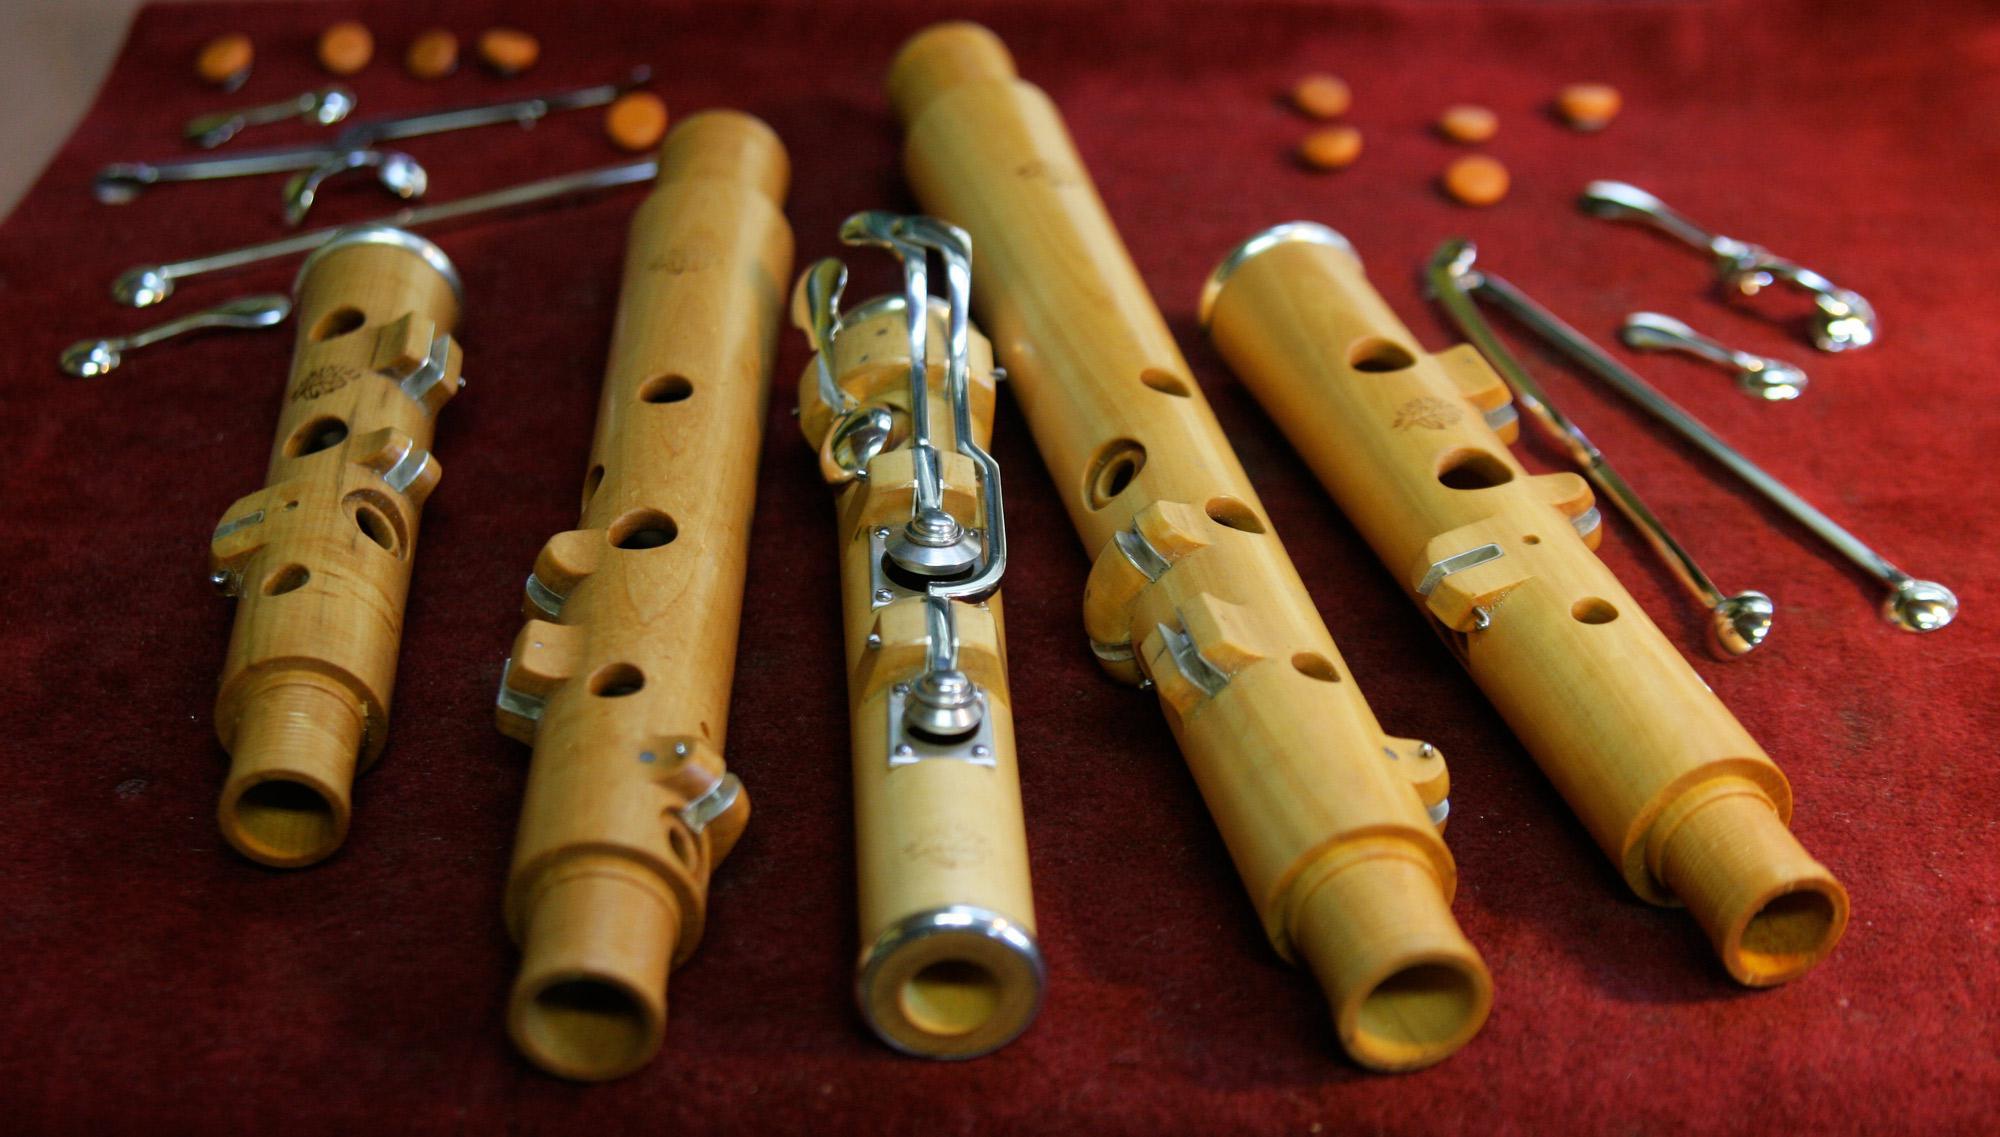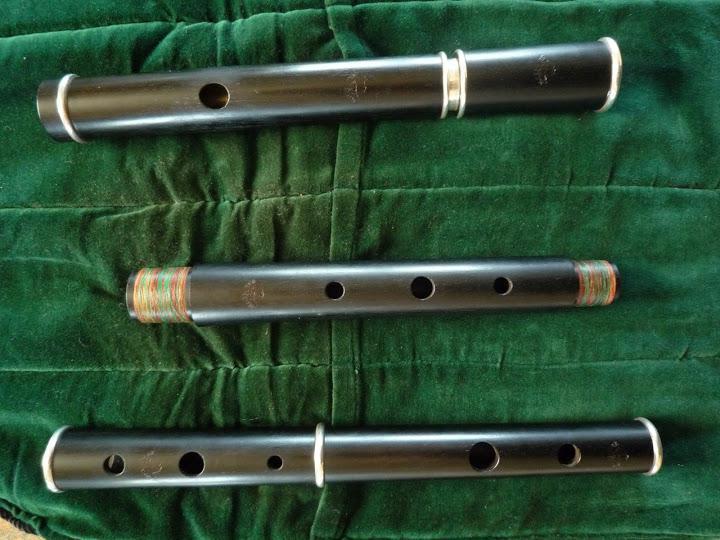The first image is the image on the left, the second image is the image on the right. Examine the images to the left and right. Is the description "In the image on the right, a brown and black case contains at least 2 sections of a flute." accurate? Answer yes or no. No. The first image is the image on the left, the second image is the image on the right. Considering the images on both sides, is "The right image features an open case and instrument parts that are not connected, and the left image includes multiple items displayed horizontally but not touching." valid? Answer yes or no. No. 